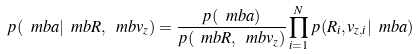Convert formula to latex. <formula><loc_0><loc_0><loc_500><loc_500>p ( \ m b { a } | \ m b { R } , \ m b { v _ { z } } ) = \frac { p ( \ m b { a } ) } { p ( \ m b { R } , \ m b { v _ { z } } ) } \prod _ { i = 1 } ^ { N } p ( R _ { i } , v _ { z , i } | \ m b { a } )</formula> 